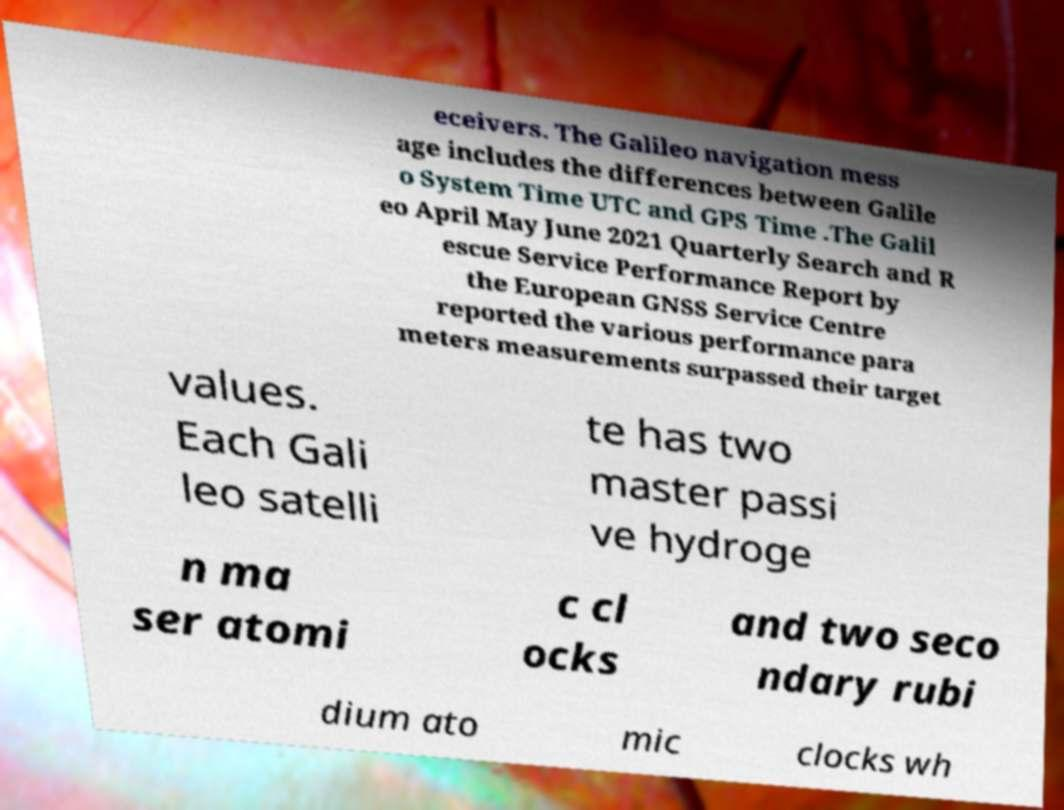Please identify and transcribe the text found in this image. eceivers. The Galileo navigation mess age includes the differences between Galile o System Time UTC and GPS Time .The Galil eo April May June 2021 Quarterly Search and R escue Service Performance Report by the European GNSS Service Centre reported the various performance para meters measurements surpassed their target values. Each Gali leo satelli te has two master passi ve hydroge n ma ser atomi c cl ocks and two seco ndary rubi dium ato mic clocks wh 